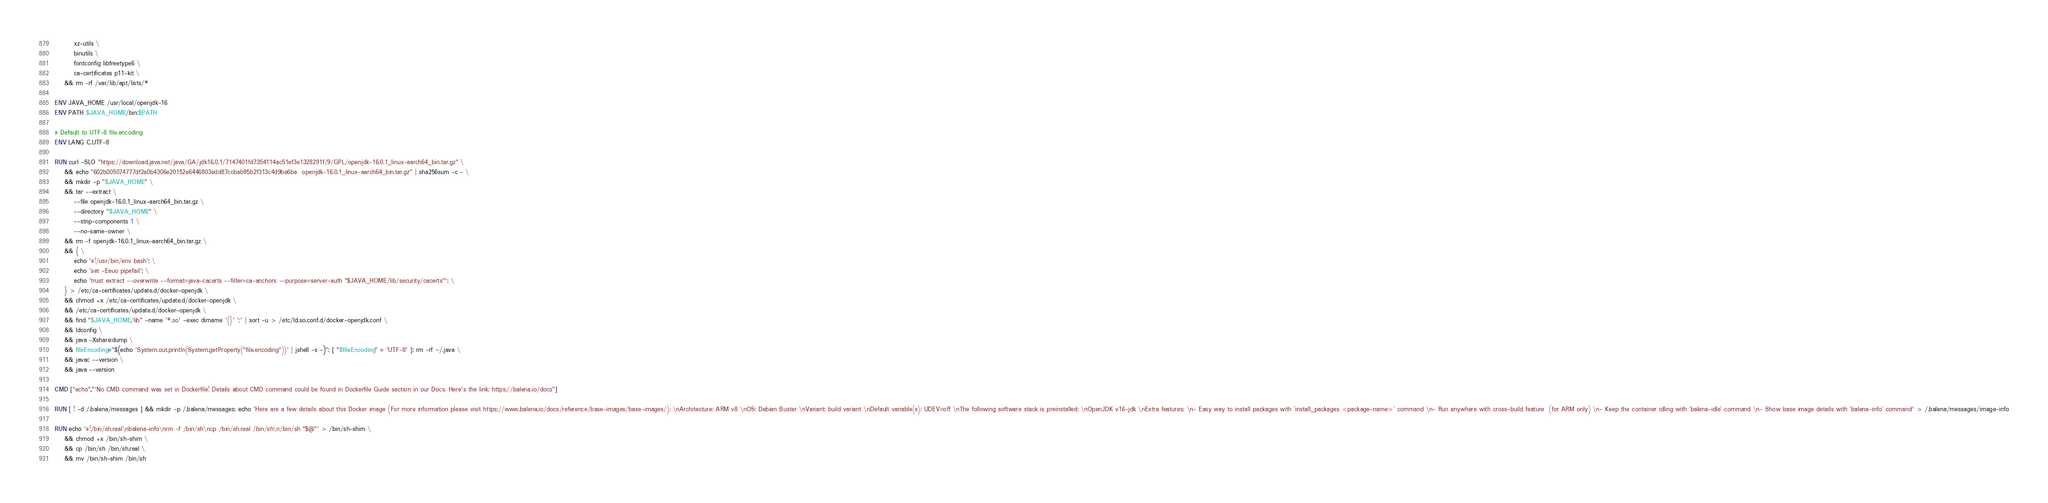Convert code to text. <code><loc_0><loc_0><loc_500><loc_500><_Dockerfile_>		xz-utils \
		binutils \
		fontconfig libfreetype6 \
		ca-certificates p11-kit \
	&& rm -rf /var/lib/apt/lists/*

ENV JAVA_HOME /usr/local/openjdk-16
ENV PATH $JAVA_HOME/bin:$PATH

# Default to UTF-8 file.encoding
ENV LANG C.UTF-8

RUN curl -SLO "https://download.java.net/java/GA/jdk16.0.1/7147401fd7354114ac51ef3e1328291f/9/GPL/openjdk-16.0.1_linux-aarch64_bin.tar.gz" \
	&& echo "602b005074777df2a0b4306e20152a6446803edd87ccbab95b2f313c4d9be6ba  openjdk-16.0.1_linux-aarch64_bin.tar.gz" | sha256sum -c - \
	&& mkdir -p "$JAVA_HOME" \
	&& tar --extract \
		--file openjdk-16.0.1_linux-aarch64_bin.tar.gz \
		--directory "$JAVA_HOME" \
		--strip-components 1 \
		--no-same-owner \
	&& rm -f openjdk-16.0.1_linux-aarch64_bin.tar.gz \
	&& { \
		echo '#!/usr/bin/env bash'; \
		echo 'set -Eeuo pipefail'; \
		echo 'trust extract --overwrite --format=java-cacerts --filter=ca-anchors --purpose=server-auth "$JAVA_HOME/lib/security/cacerts"'; \
	} > /etc/ca-certificates/update.d/docker-openjdk \
	&& chmod +x /etc/ca-certificates/update.d/docker-openjdk \
	&& /etc/ca-certificates/update.d/docker-openjdk \
	&& find "$JAVA_HOME/lib" -name '*.so' -exec dirname '{}' ';' | sort -u > /etc/ld.so.conf.d/docker-openjdk.conf \
	&& ldconfig \
	&& java -Xshare:dump \
	&& fileEncoding="$(echo 'System.out.println(System.getProperty("file.encoding"))' | jshell -s -)"; [ "$fileEncoding" = 'UTF-8' ]; rm -rf ~/.java \
	&& javac --version \
	&& java --version

CMD ["echo","'No CMD command was set in Dockerfile! Details about CMD command could be found in Dockerfile Guide section in our Docs. Here's the link: https://balena.io/docs"]

RUN [ ! -d /.balena/messages ] && mkdir -p /.balena/messages; echo 'Here are a few details about this Docker image (For more information please visit https://www.balena.io/docs/reference/base-images/base-images/): \nArchitecture: ARM v8 \nOS: Debian Buster \nVariant: build variant \nDefault variable(s): UDEV=off \nThe following software stack is preinstalled: \nOpenJDK v16-jdk \nExtra features: \n- Easy way to install packages with `install_packages <package-name>` command \n- Run anywhere with cross-build feature  (for ARM only) \n- Keep the container idling with `balena-idle` command \n- Show base image details with `balena-info` command' > /.balena/messages/image-info

RUN echo '#!/bin/sh.real\nbalena-info\nrm -f /bin/sh\ncp /bin/sh.real /bin/sh\n/bin/sh "$@"' > /bin/sh-shim \
	&& chmod +x /bin/sh-shim \
	&& cp /bin/sh /bin/sh.real \
	&& mv /bin/sh-shim /bin/sh</code> 